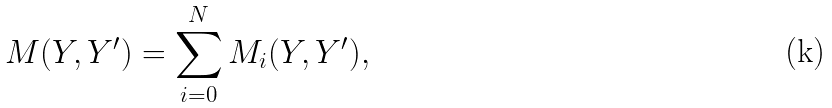Convert formula to latex. <formula><loc_0><loc_0><loc_500><loc_500>M ( { Y } , { Y } ^ { \prime } ) = \sum ^ { N } _ { i = 0 } M _ { i } ( { Y } , { Y } ^ { \prime } ) ,</formula> 